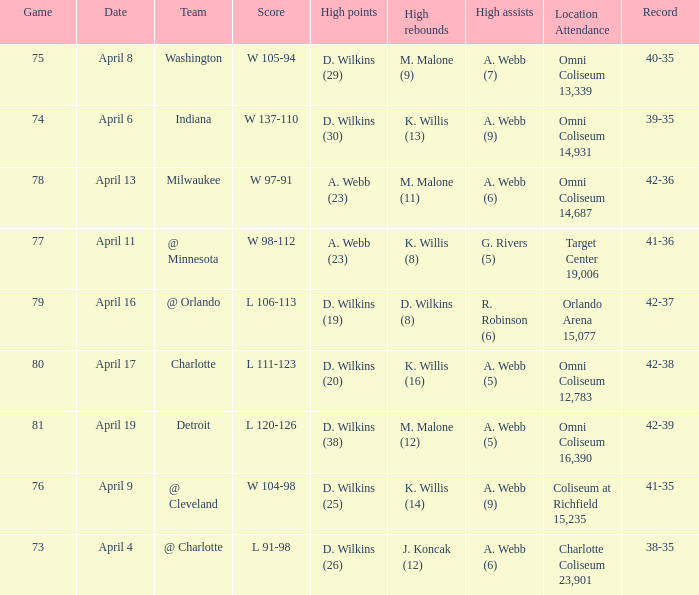What date was the game score w 104-98? April 9. 